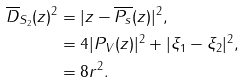Convert formula to latex. <formula><loc_0><loc_0><loc_500><loc_500>\overline { D } _ { S _ { 2 } } ( z ) ^ { 2 } & = | z - \overline { P _ { s } } ( z ) | ^ { 2 } , \\ & = 4 | P _ { V } ( z ) | ^ { 2 } + | \xi _ { 1 } - \xi _ { 2 } | ^ { 2 } , \\ & = 8 r ^ { 2 } .</formula> 